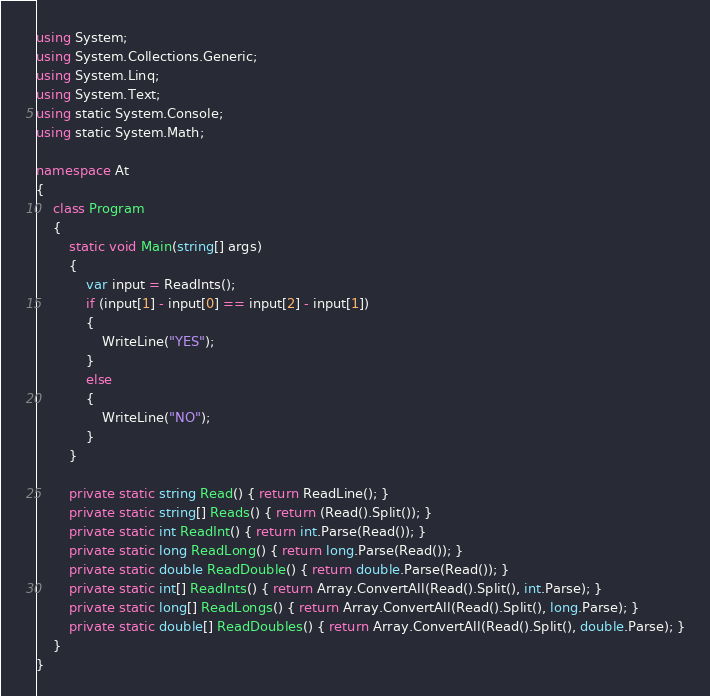<code> <loc_0><loc_0><loc_500><loc_500><_C#_>using System;
using System.Collections.Generic;
using System.Linq;
using System.Text;
using static System.Console;
using static System.Math;

namespace At
{
    class Program
    {
        static void Main(string[] args)
        {
            var input = ReadInts();
            if (input[1] - input[0] == input[2] - input[1])
            {
                WriteLine("YES");
            }
            else
            {
                WriteLine("NO");
            }
        }

        private static string Read() { return ReadLine(); }
        private static string[] Reads() { return (Read().Split()); }
        private static int ReadInt() { return int.Parse(Read()); }
        private static long ReadLong() { return long.Parse(Read()); }
        private static double ReadDouble() { return double.Parse(Read()); }
        private static int[] ReadInts() { return Array.ConvertAll(Read().Split(), int.Parse); }
        private static long[] ReadLongs() { return Array.ConvertAll(Read().Split(), long.Parse); }
        private static double[] ReadDoubles() { return Array.ConvertAll(Read().Split(), double.Parse); }
    }
}
</code> 